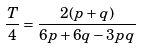<formula> <loc_0><loc_0><loc_500><loc_500>\frac { T } { 4 } = \frac { 2 ( p + q ) } { 6 p + 6 q - 3 p q }</formula> 